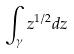Convert formula to latex. <formula><loc_0><loc_0><loc_500><loc_500>\int _ { \gamma } z ^ { 1 / 2 } d z</formula> 